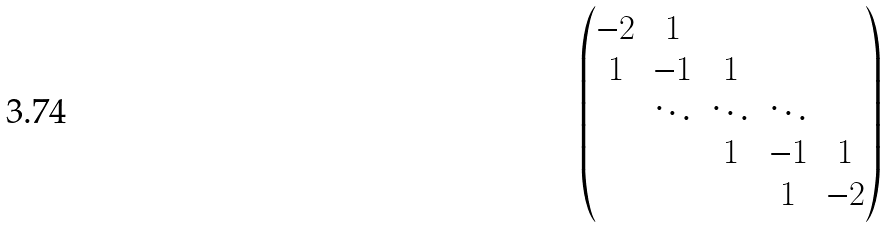Convert formula to latex. <formula><loc_0><loc_0><loc_500><loc_500>\begin{pmatrix} - 2 & 1 & & & \\ 1 & - 1 & 1 & & \\ & \ddots & \ddots & \ddots & \\ & & 1 & - 1 & 1 \\ & & & 1 & - 2 \end{pmatrix}</formula> 